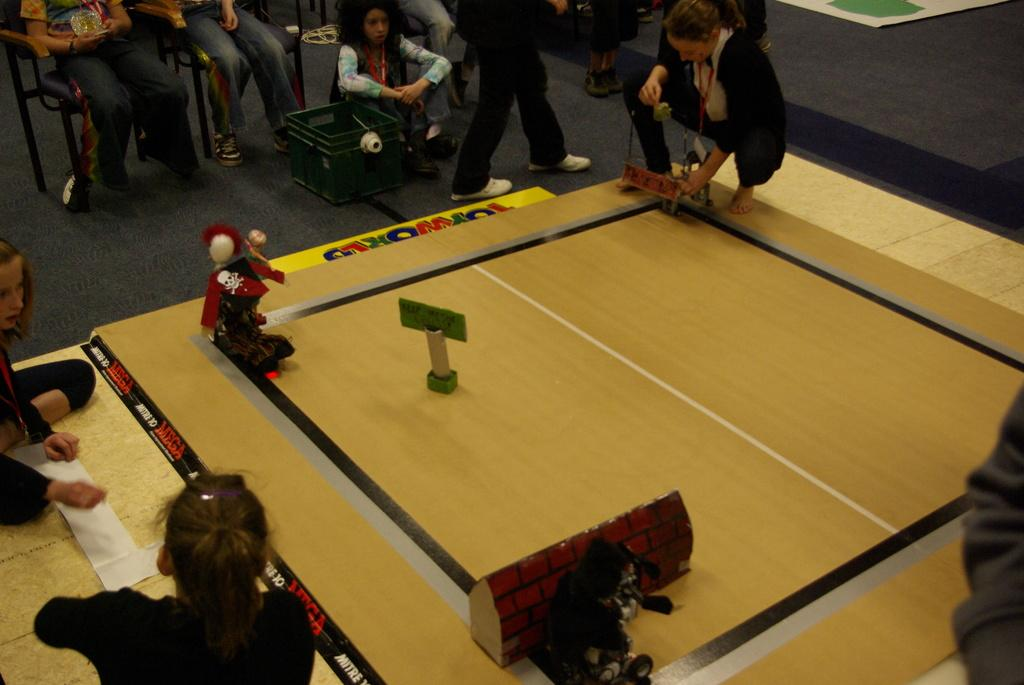What is the main activity being depicted in the image? There is a person playing at a board in the image. Can you describe the position of the second person in the image? There is a person sitting at the top of the image. What type of bubble can be seen floating around the person playing at the board in the image? There is no bubble present in the image. 